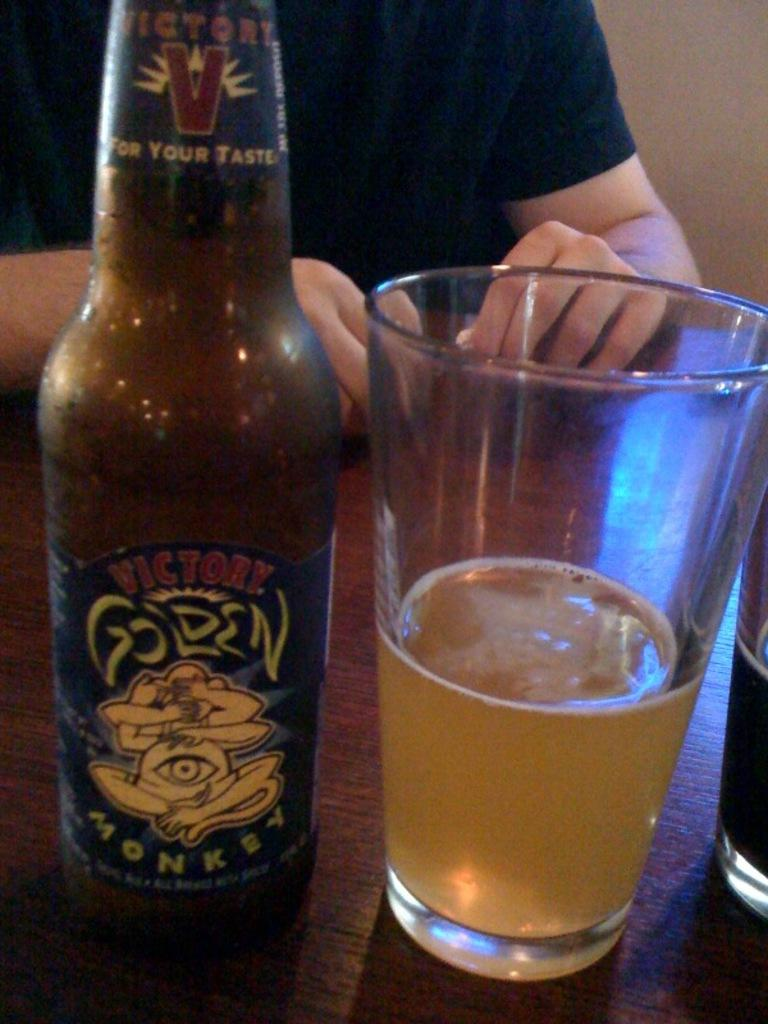What type of beverage container is in the image? There is a wine bottle in the image. What is the wine bottle accompanied by? There is a wine glass in the image. Where are the wine bottle and glass located? Both the wine bottle and glass are on a table. Is there a person in the image? Yes, there is a person sitting in front of the table. Can you tell me how many people are playing on the board in the image? There is no board or people playing in the image; it features a wine bottle, wine glass, and a person sitting in front of a table. 